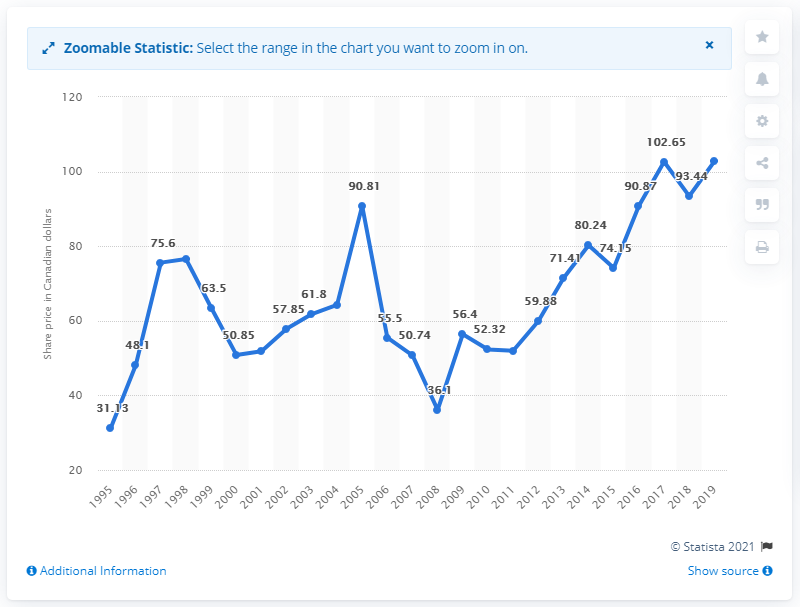Mention a couple of crucial points in this snapshot. In 2019, the common share price of Royal Bank of Canada was $102.75 in US dollars. 